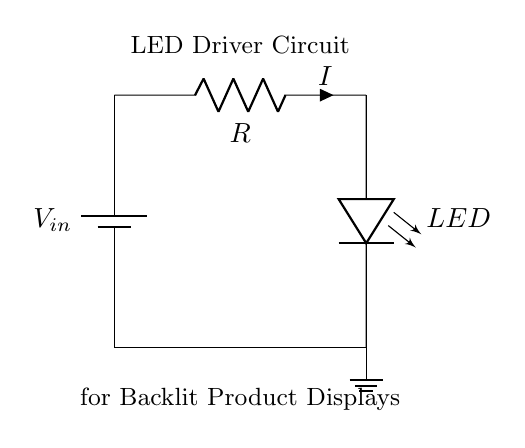What is the input voltage of the circuit? The input voltage is represented by \( V_{in} \) at the battery, which is a key component for powering the circuit.
Answer: V_in What component limits the current through the LED? The resistor \( R \) is in series with the LED and provides a path to limit the amount of current that flows, helping to prevent damage to the LED from excess current.
Answer: R What is the purpose of the LED in this circuit? The purpose of the LED is to provide illumination for the backlit display, acting as the light source when a current flows through it, effectively lightening up the display area.
Answer: Illumination What is the direction of current flow in this circuit? Current flows from the positive terminal of the battery through the resistor and then through the LED, returning to the negative terminal, completing the circuit.
Answer: Positive to negative What will happen if the resistor value is decreased? Decreasing the resistor value will allow more current to flow through the circuit, which can result in a brighter LED, but it may also risk damaging the LED if the current exceeds its rated specifications.
Answer: Increased brightness Why is the ground connection important in this circuit? The ground connection serves as a reference point for the voltage in the circuit and provides a return path for current flow, ensuring that the circuit has a completed path for the flow of electricity.
Answer: Reference and return path 